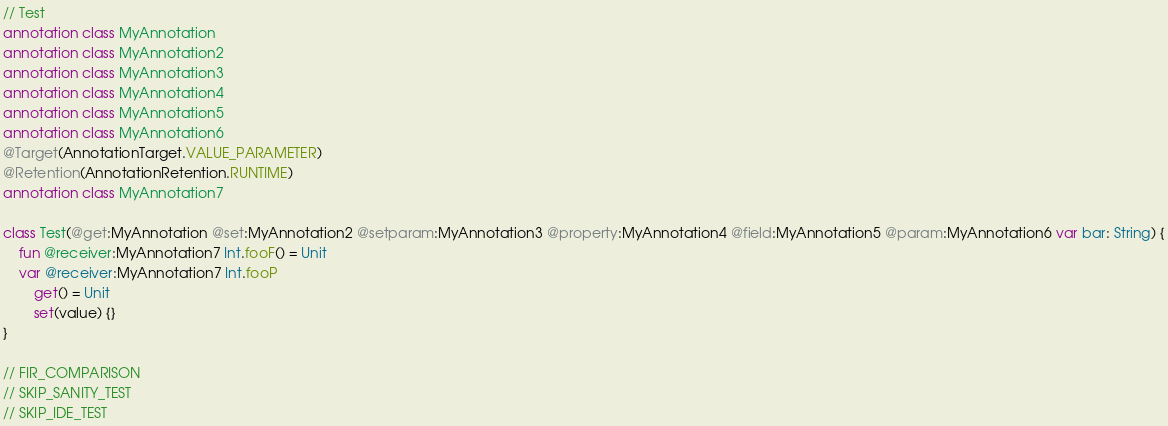<code> <loc_0><loc_0><loc_500><loc_500><_Kotlin_>// Test
annotation class MyAnnotation
annotation class MyAnnotation2
annotation class MyAnnotation3
annotation class MyAnnotation4
annotation class MyAnnotation5
annotation class MyAnnotation6
@Target(AnnotationTarget.VALUE_PARAMETER)
@Retention(AnnotationRetention.RUNTIME)
annotation class MyAnnotation7

class Test(@get:MyAnnotation @set:MyAnnotation2 @setparam:MyAnnotation3 @property:MyAnnotation4 @field:MyAnnotation5 @param:MyAnnotation6 var bar: String) {
    fun @receiver:MyAnnotation7 Int.fooF() = Unit
    var @receiver:MyAnnotation7 Int.fooP
        get() = Unit
        set(value) {}
}

// FIR_COMPARISON
// SKIP_SANITY_TEST
// SKIP_IDE_TEST</code> 